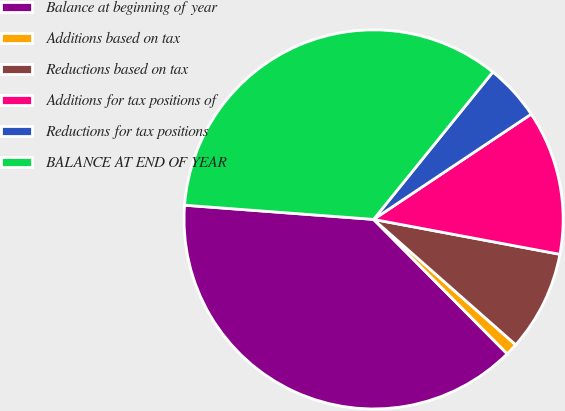<chart> <loc_0><loc_0><loc_500><loc_500><pie_chart><fcel>Balance at beginning of year<fcel>Additions based on tax<fcel>Reductions based on tax<fcel>Additions for tax positions of<fcel>Reductions for tax positions<fcel>BALANCE AT END OF YEAR<nl><fcel>38.65%<fcel>1.04%<fcel>8.56%<fcel>12.32%<fcel>4.8%<fcel>34.64%<nl></chart> 